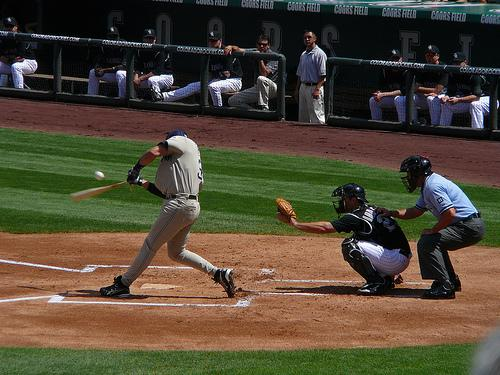How many people are actively involved in the baseball game scene, and what are their roles? There are three people actively involved: a batter swinging a bat to hit the ball, a catcher waiting to catch the ball, and an umpire watching the play. Mention the actions and positions of the main players in the baseball game. A batter is getting ready to hit a ball, a catcher is waiting to catch the ball behind home plate, and an umpire is watching the play near the catcher. Explain the complex reasoning task in the image. The task involves understanding the relationships between various elements like position and interaction of players, their roles, and objects associated with the game. List the colors of specific elements in the scene such as grass, dirt, ball, bat, and umpire's shirt. The grass is green, the dirt is brown, the ball is white, the baseball bat is brown, and the umpire's shirt is blue. Count the number of significant objects related to the baseball game and mention their names. There are 9 significant objects: grass, dirt, baseball, baseball bat, mitt, home plate, white lines on the field, baseball glove, and catchers mitt. Describe the emotions the image evokes. The image evokes an energetic atmosphere of competition, teamwork, and excitement as the players and spectators are immersed in the baseball game. Identify the objects in the air and provide their colors. A white baseball is in midair. Elaborate on the interaction between the catcher and the baseball. The catcher, wearing a brown mitt, has his arm extended and is preparing to catch the white baseball in midair. Provide a brief overview of the spectators in the image. Numerous team members are on the sideline, a man in a gray polo shirt is standing, and people are sitting at the edge of the field. In an expressive manner, describe the condition of the home plate. The home plate is covered in red dirt, making it appear quite messy and well-used in the game. 